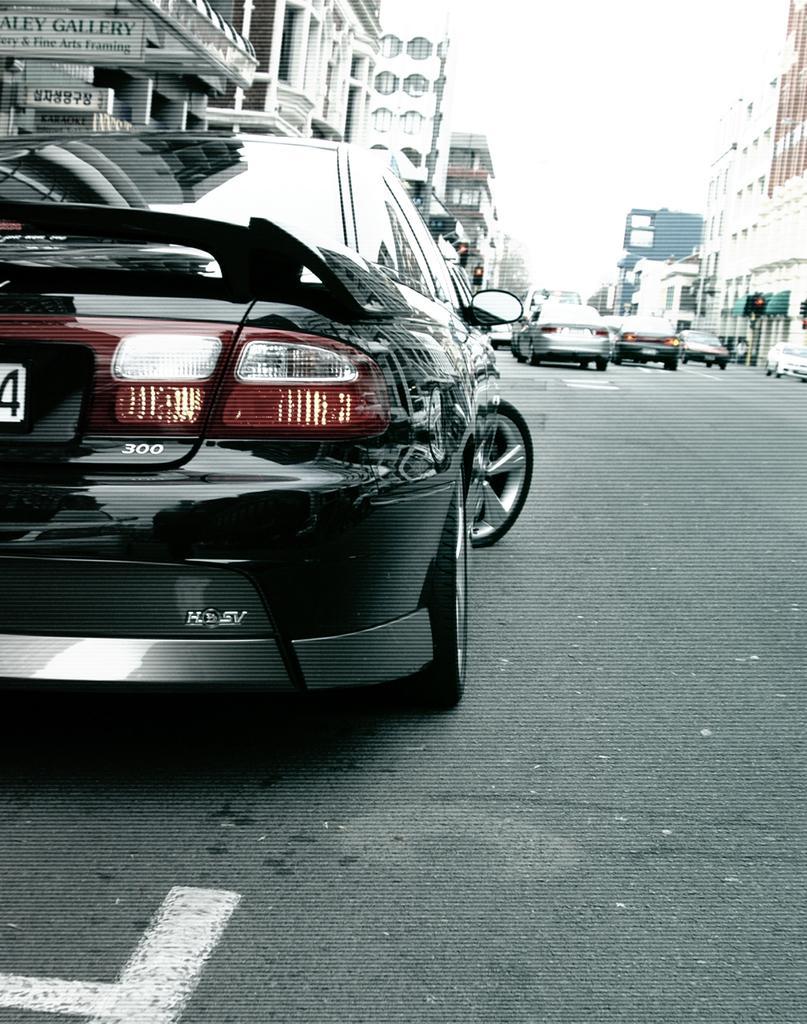How would you summarize this image in a sentence or two? There is a black color vehicle on the road. On both sides of this road, there are buildings. In the background, there is sky. 